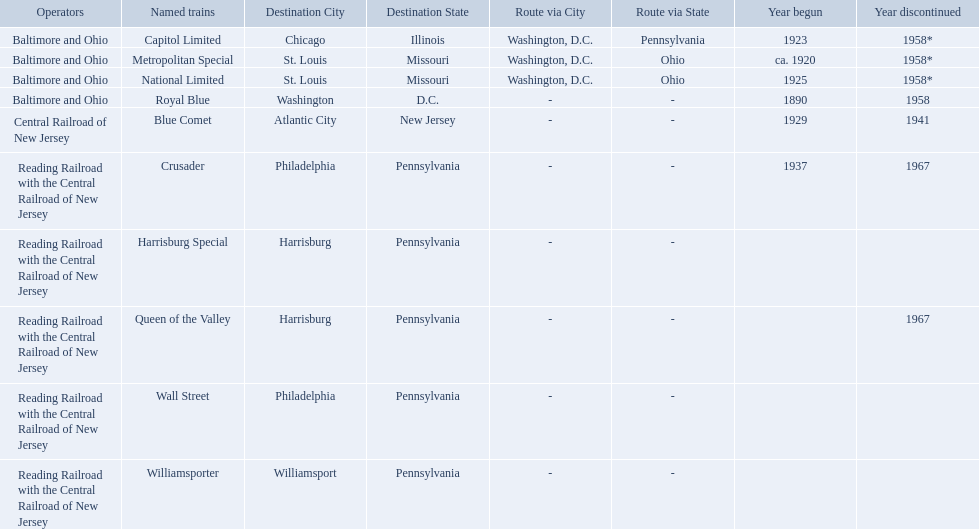What were all of the destinations? Chicago, Illinois via Washington, D.C. and Pittsburgh, Pennsylvania, St. Louis, Missouri via Washington, D.C. and Cincinnati, Ohio, St. Louis, Missouri via Washington, D.C. and Cincinnati, Ohio, Washington, D.C., Atlantic City, New Jersey, Philadelphia, Pennsylvania, Harrisburg, Pennsylvania, Harrisburg, Pennsylvania, Philadelphia, Pennsylvania, Williamsport, Pennsylvania. And what were the names of the trains? Capitol Limited, Metropolitan Special, National Limited, Royal Blue, Blue Comet, Crusader, Harrisburg Special, Queen of the Valley, Wall Street, Williamsporter. Of those, and along with wall street, which train ran to philadelphia, pennsylvania? Crusader. 